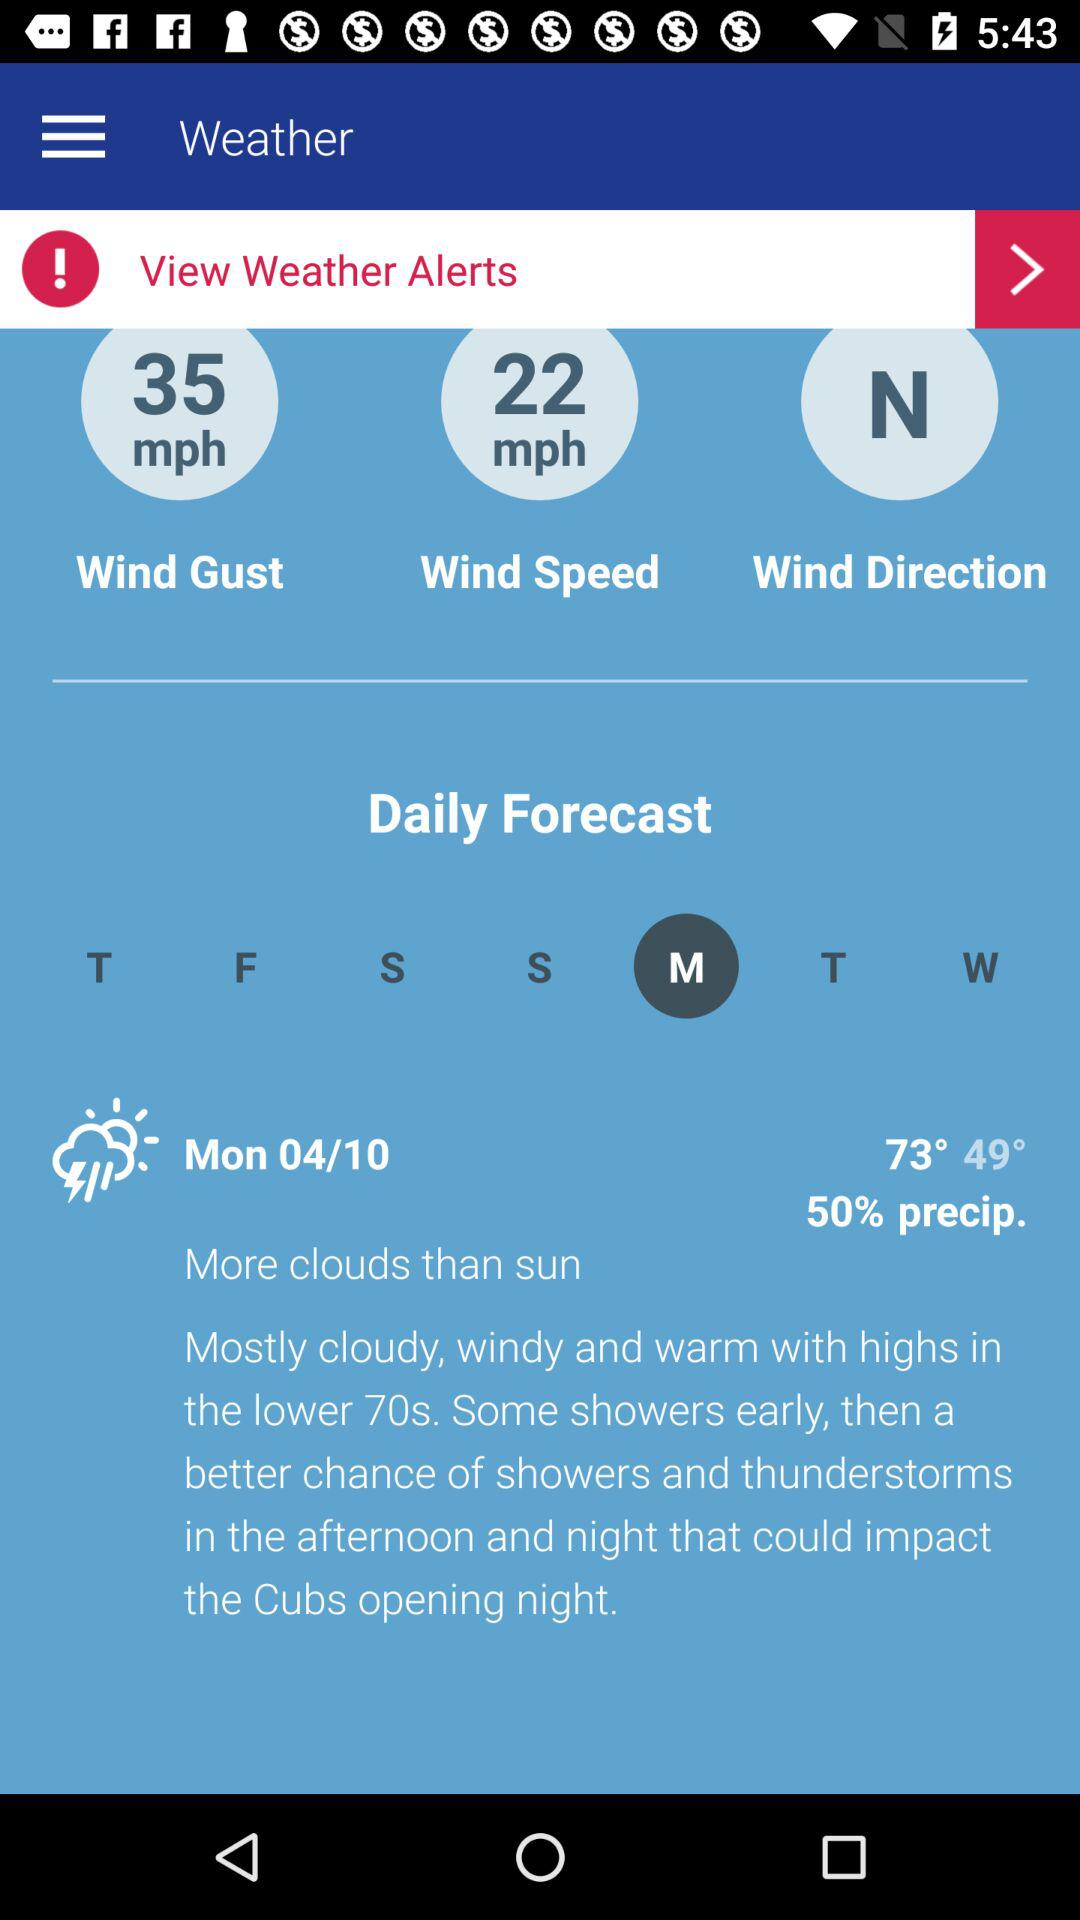What is the weather today? Today's weather is "Mostly cloudy, windy and warm with highs in the lower 70s. Some showers early, then a better chance of showers and thunderstorms in the afternoon and night that could impact the Cubs opening night.". 